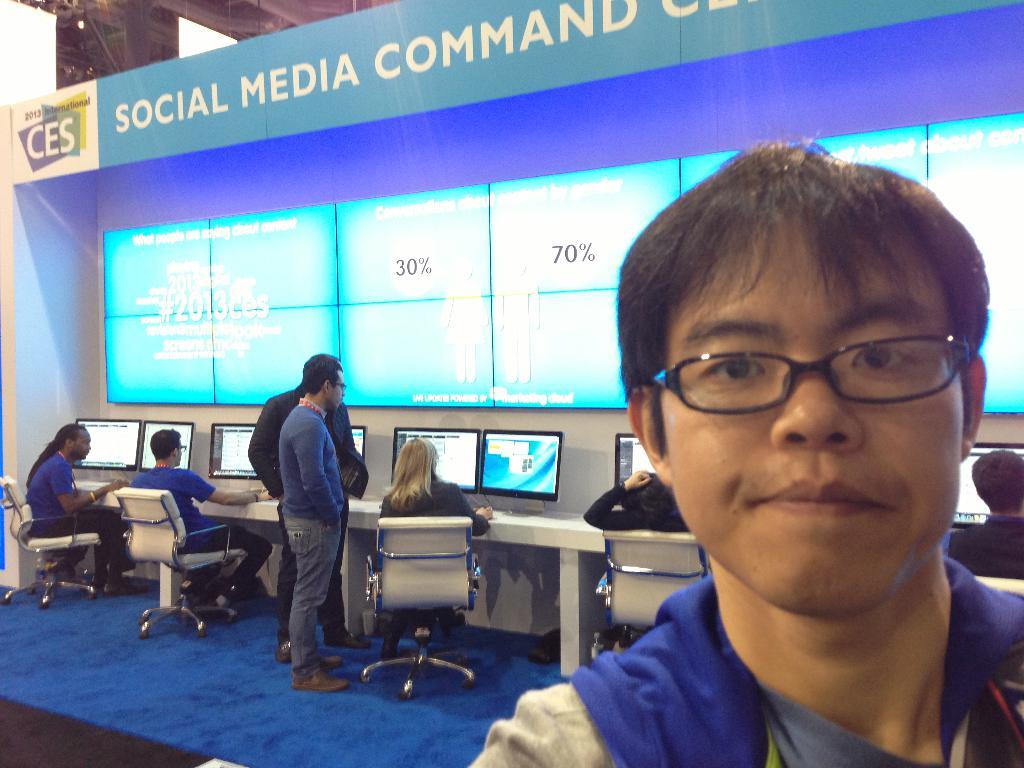What is the person in the image wearing on their face? The person in the image is wearing spectacles. What are the people in the background doing? The group of people in the background are sitting on chairs. What objects are on the table in the background? There are monitors on a table in the background. What is present in the background besides the group of people and the table with monitors? There is a screen, a board, and focus lights in the background. Can you see a banana on the table with the monitors? No, there is no banana present on the table with the monitors in the image. Is there a snail crawling on the board in the background? No, there is no snail present on the board in the background of the image. 